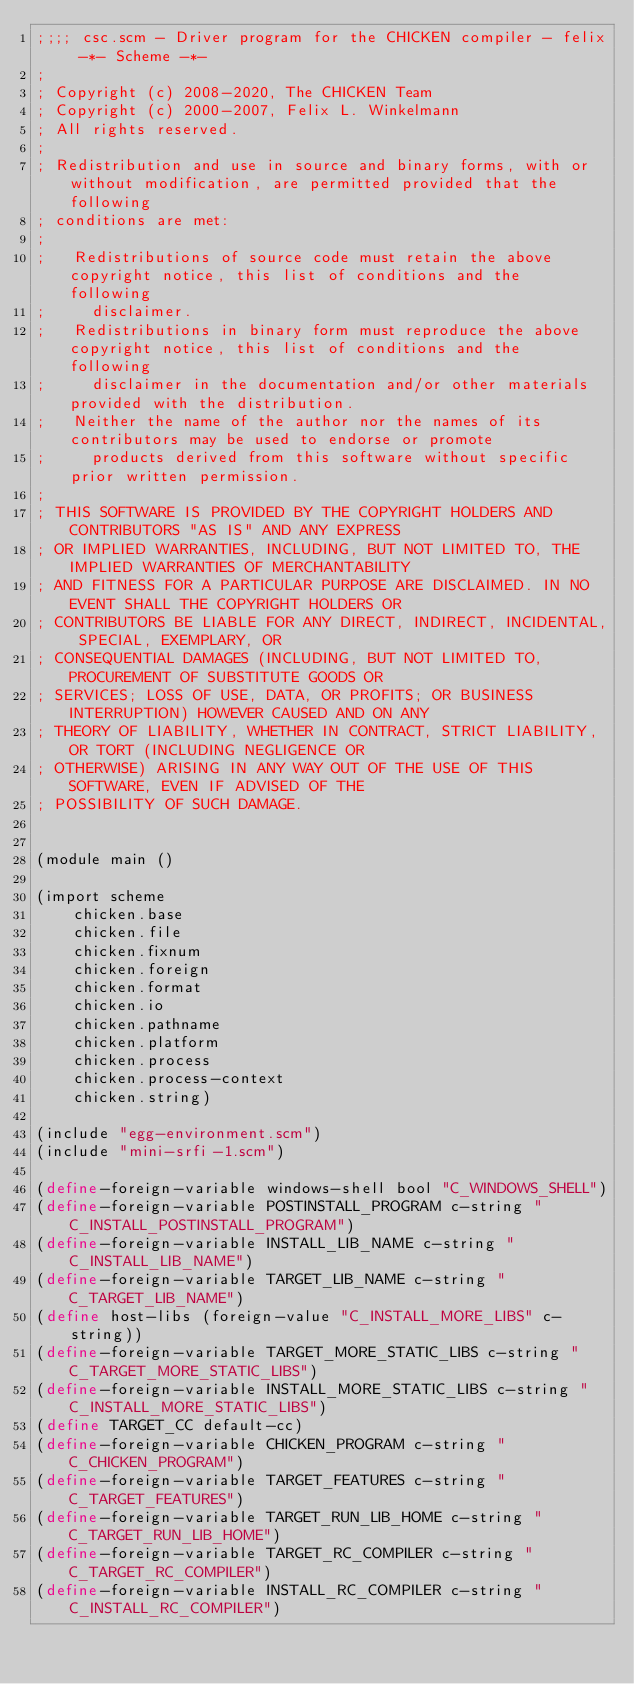<code> <loc_0><loc_0><loc_500><loc_500><_Scheme_>;;;; csc.scm - Driver program for the CHICKEN compiler - felix -*- Scheme -*-
;
; Copyright (c) 2008-2020, The CHICKEN Team
; Copyright (c) 2000-2007, Felix L. Winkelmann
; All rights reserved.
;
; Redistribution and use in source and binary forms, with or without modification, are permitted provided that the following
; conditions are met:
;
;   Redistributions of source code must retain the above copyright notice, this list of conditions and the following
;     disclaimer. 
;   Redistributions in binary form must reproduce the above copyright notice, this list of conditions and the following
;     disclaimer in the documentation and/or other materials provided with the distribution. 
;   Neither the name of the author nor the names of its contributors may be used to endorse or promote
;     products derived from this software without specific prior written permission. 
;
; THIS SOFTWARE IS PROVIDED BY THE COPYRIGHT HOLDERS AND CONTRIBUTORS "AS IS" AND ANY EXPRESS
; OR IMPLIED WARRANTIES, INCLUDING, BUT NOT LIMITED TO, THE IMPLIED WARRANTIES OF MERCHANTABILITY
; AND FITNESS FOR A PARTICULAR PURPOSE ARE DISCLAIMED. IN NO EVENT SHALL THE COPYRIGHT HOLDERS OR
; CONTRIBUTORS BE LIABLE FOR ANY DIRECT, INDIRECT, INCIDENTAL, SPECIAL, EXEMPLARY, OR
; CONSEQUENTIAL DAMAGES (INCLUDING, BUT NOT LIMITED TO, PROCUREMENT OF SUBSTITUTE GOODS OR
; SERVICES; LOSS OF USE, DATA, OR PROFITS; OR BUSINESS INTERRUPTION) HOWEVER CAUSED AND ON ANY
; THEORY OF LIABILITY, WHETHER IN CONTRACT, STRICT LIABILITY, OR TORT (INCLUDING NEGLIGENCE OR
; OTHERWISE) ARISING IN ANY WAY OUT OF THE USE OF THIS SOFTWARE, EVEN IF ADVISED OF THE
; POSSIBILITY OF SUCH DAMAGE.


(module main ()

(import scheme
	chicken.base
	chicken.file
	chicken.fixnum
	chicken.foreign
	chicken.format
	chicken.io
	chicken.pathname
	chicken.platform
	chicken.process
	chicken.process-context
	chicken.string)

(include "egg-environment.scm")
(include "mini-srfi-1.scm")

(define-foreign-variable windows-shell bool "C_WINDOWS_SHELL")
(define-foreign-variable POSTINSTALL_PROGRAM c-string "C_INSTALL_POSTINSTALL_PROGRAM")
(define-foreign-variable INSTALL_LIB_NAME c-string "C_INSTALL_LIB_NAME")
(define-foreign-variable TARGET_LIB_NAME c-string "C_TARGET_LIB_NAME")
(define host-libs (foreign-value "C_INSTALL_MORE_LIBS" c-string))
(define-foreign-variable TARGET_MORE_STATIC_LIBS c-string "C_TARGET_MORE_STATIC_LIBS")
(define-foreign-variable INSTALL_MORE_STATIC_LIBS c-string "C_INSTALL_MORE_STATIC_LIBS")
(define TARGET_CC default-cc)
(define-foreign-variable CHICKEN_PROGRAM c-string "C_CHICKEN_PROGRAM")
(define-foreign-variable TARGET_FEATURES c-string "C_TARGET_FEATURES")
(define-foreign-variable TARGET_RUN_LIB_HOME c-string "C_TARGET_RUN_LIB_HOME")
(define-foreign-variable TARGET_RC_COMPILER c-string "C_TARGET_RC_COMPILER")
(define-foreign-variable INSTALL_RC_COMPILER c-string "C_INSTALL_RC_COMPILER")</code> 